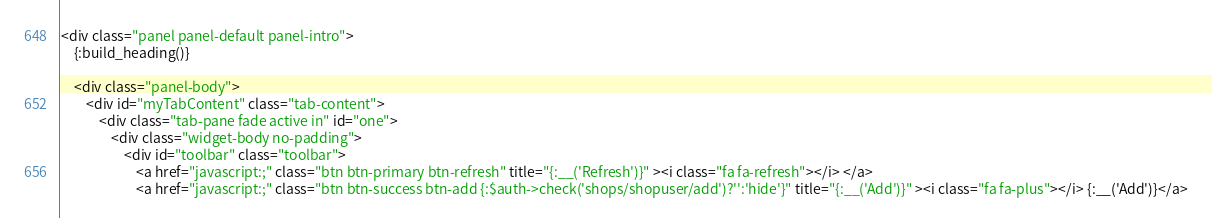Convert code to text. <code><loc_0><loc_0><loc_500><loc_500><_HTML_><div class="panel panel-default panel-intro">
    {:build_heading()}

    <div class="panel-body">
        <div id="myTabContent" class="tab-content">
            <div class="tab-pane fade active in" id="one">
                <div class="widget-body no-padding">
                    <div id="toolbar" class="toolbar">
                        <a href="javascript:;" class="btn btn-primary btn-refresh" title="{:__('Refresh')}" ><i class="fa fa-refresh"></i> </a>
                        <a href="javascript:;" class="btn btn-success btn-add {:$auth->check('shops/shopuser/add')?'':'hide'}" title="{:__('Add')}" ><i class="fa fa-plus"></i> {:__('Add')}</a></code> 